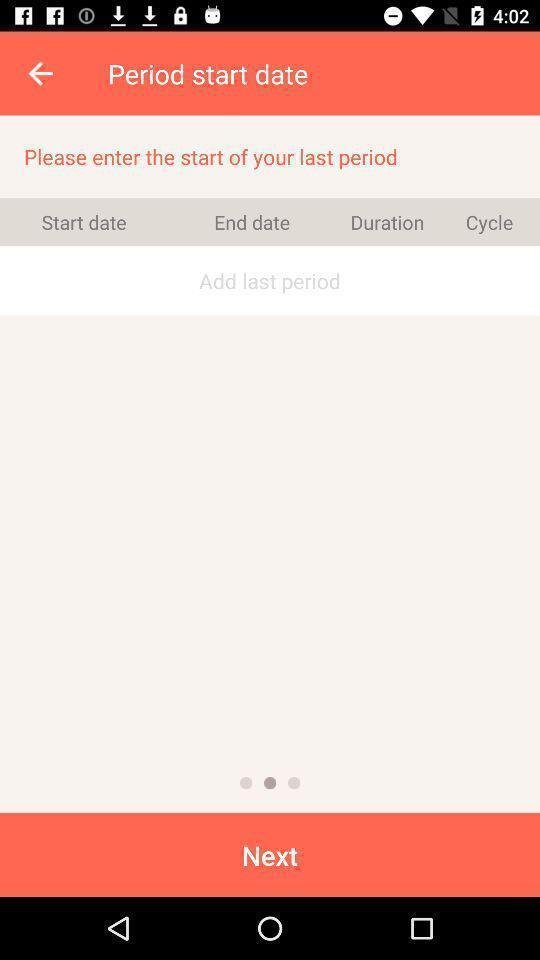Summarize the information in this screenshot. Window displaying menstruation recording calendar. 